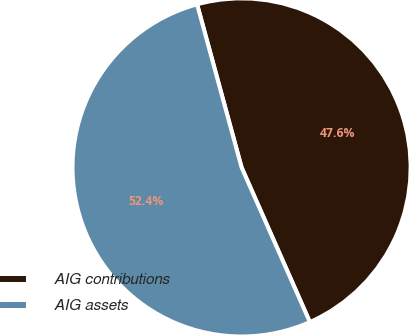Convert chart to OTSL. <chart><loc_0><loc_0><loc_500><loc_500><pie_chart><fcel>AIG contributions<fcel>AIG assets<nl><fcel>47.62%<fcel>52.38%<nl></chart> 